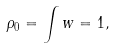Convert formula to latex. <formula><loc_0><loc_0><loc_500><loc_500>\rho _ { 0 } = \int w = 1 ,</formula> 